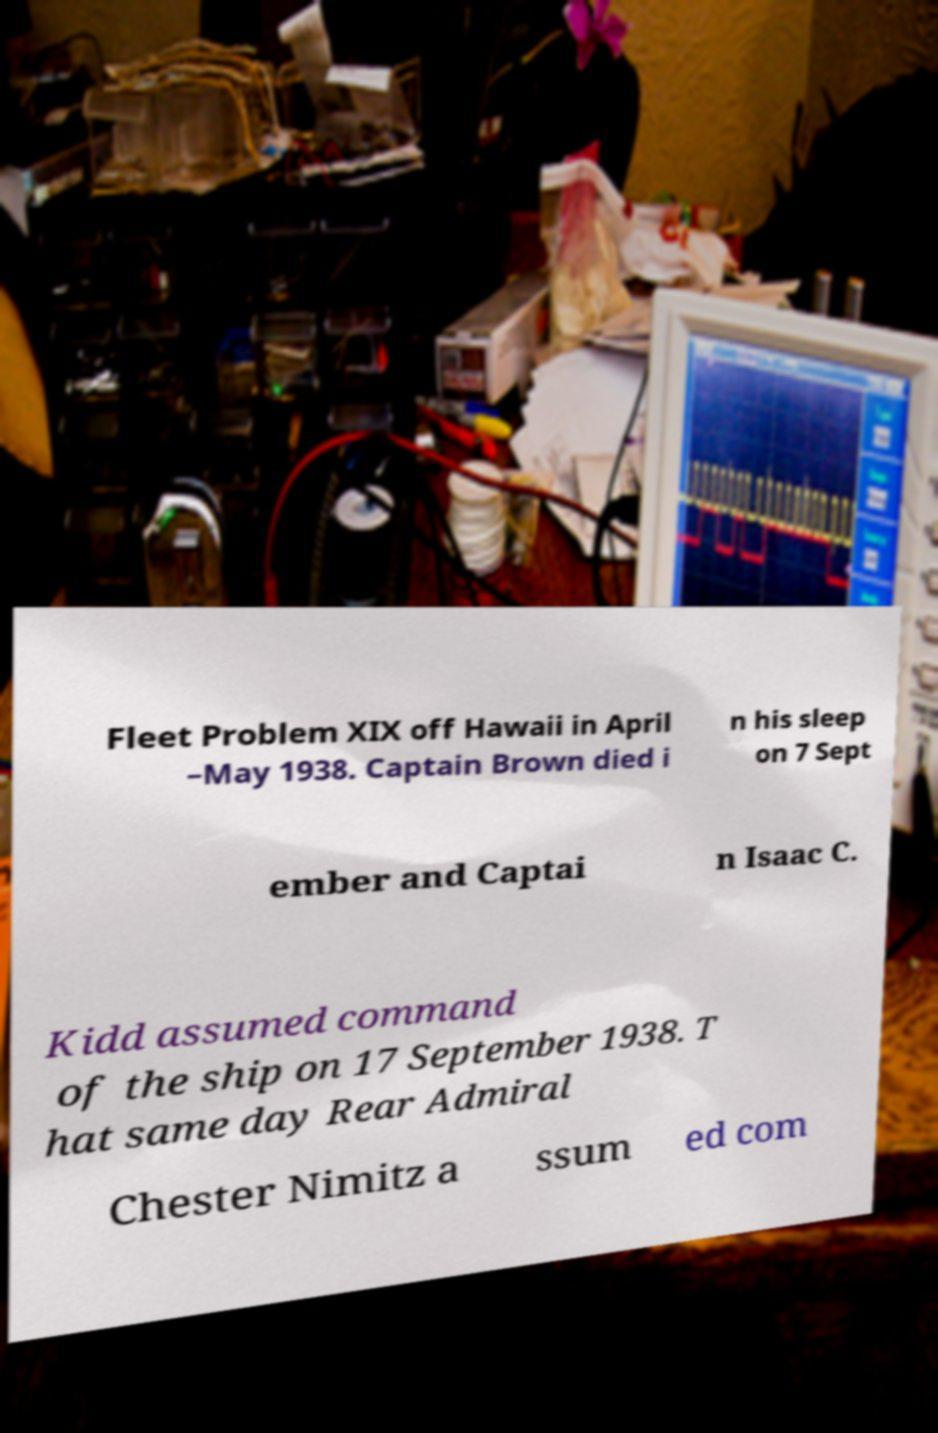For documentation purposes, I need the text within this image transcribed. Could you provide that? Fleet Problem XIX off Hawaii in April –May 1938. Captain Brown died i n his sleep on 7 Sept ember and Captai n Isaac C. Kidd assumed command of the ship on 17 September 1938. T hat same day Rear Admiral Chester Nimitz a ssum ed com 